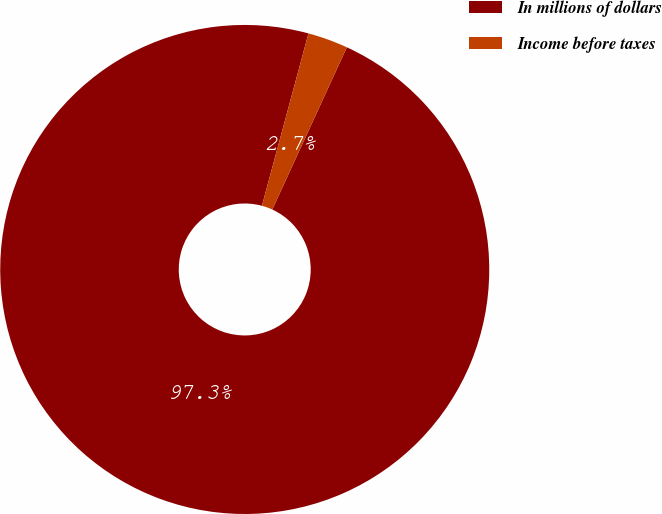Convert chart to OTSL. <chart><loc_0><loc_0><loc_500><loc_500><pie_chart><fcel>In millions of dollars<fcel>Income before taxes<nl><fcel>97.34%<fcel>2.66%<nl></chart> 